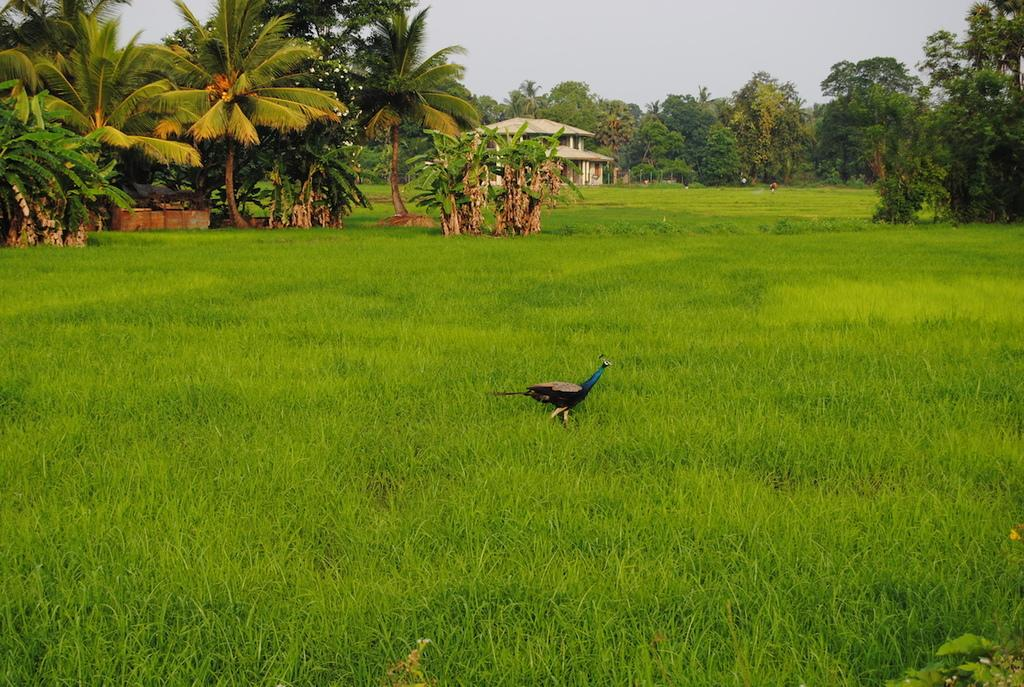What animal is the main subject of the image? There is a peacock in the image. Where is the peacock located? The peacock is on the grass. What type of vegetation can be seen in the image? There are trees and plants visible in the image. What structure is present in the image? There is a shelter in the image. What is visible at the top of the image? The sky is visible at the top of the image. What type of shoes is the peacock wearing in the image? Peacocks do not wear shoes, so there is no mention of shoes in the image. 